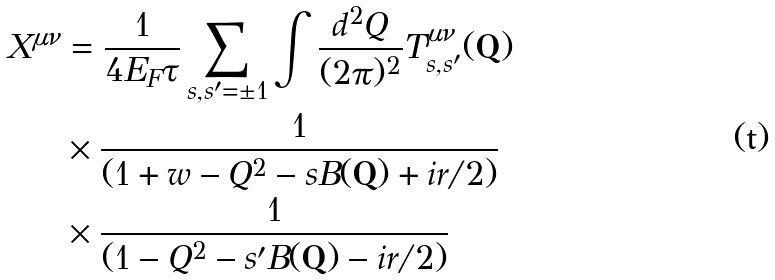Convert formula to latex. <formula><loc_0><loc_0><loc_500><loc_500>X ^ { \mu \nu } & = \frac { 1 } { 4 E _ { F } \tau } \sum _ { s , s ^ { \prime } = \pm 1 } \int \frac { d ^ { 2 } Q } { ( 2 \pi ) ^ { 2 } } T _ { s , s ^ { \prime } } ^ { \mu \nu } ( \mathbf Q ) \\ & \times \frac { 1 } { ( 1 + w - Q ^ { 2 } - s B ( \mathbf Q ) + i r / 2 ) } \\ & \times \frac { 1 } { ( 1 - Q ^ { 2 } - s ^ { \prime } B ( \mathbf Q ) - i r / 2 ) }</formula> 